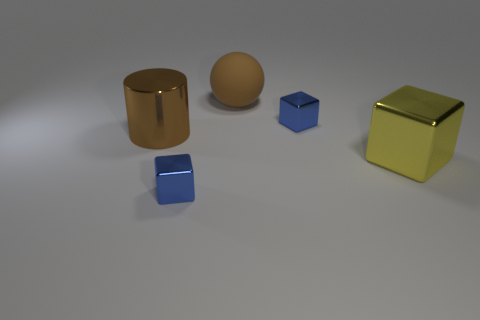Are there any other things that have the same material as the brown ball?
Provide a short and direct response. No. What number of tiny blue things have the same shape as the yellow object?
Your answer should be compact. 2. There is a cube that is left of the ball; does it have the same color as the large sphere behind the large metallic block?
Make the answer very short. No. There is a brown cylinder that is the same size as the yellow metal object; what is it made of?
Provide a succinct answer. Metal. Are there any other brown balls of the same size as the brown sphere?
Offer a very short reply. No. Are there fewer large brown matte objects that are behind the large yellow block than yellow cubes?
Give a very brief answer. No. Are there fewer balls that are on the left side of the large brown metal cylinder than yellow things that are behind the brown ball?
Provide a succinct answer. No. How many blocks are matte things or large things?
Keep it short and to the point. 1. Does the cube behind the large yellow block have the same material as the blue thing to the left of the large sphere?
Offer a terse response. Yes. There is a yellow metallic object that is the same size as the brown matte object; what shape is it?
Give a very brief answer. Cube. 